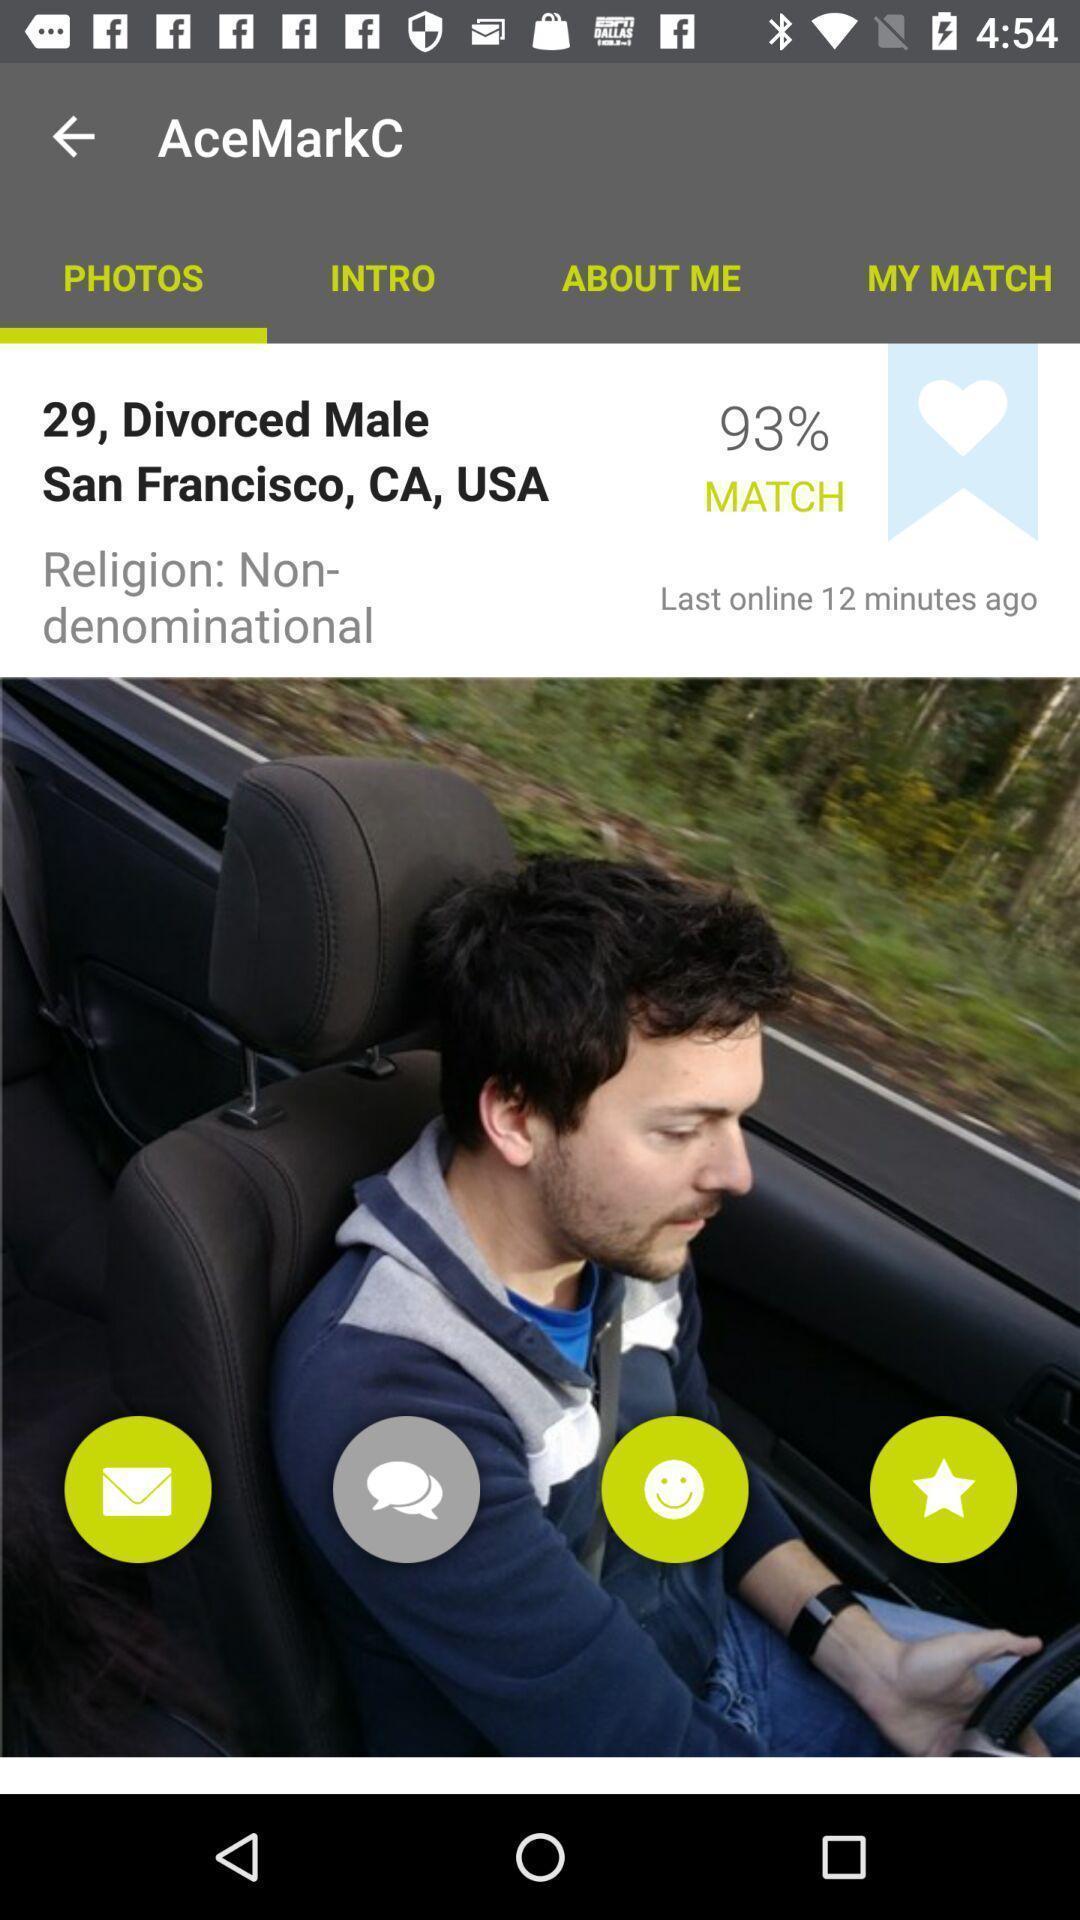Describe the content in this image. Page shows a profile in the relationship app. 